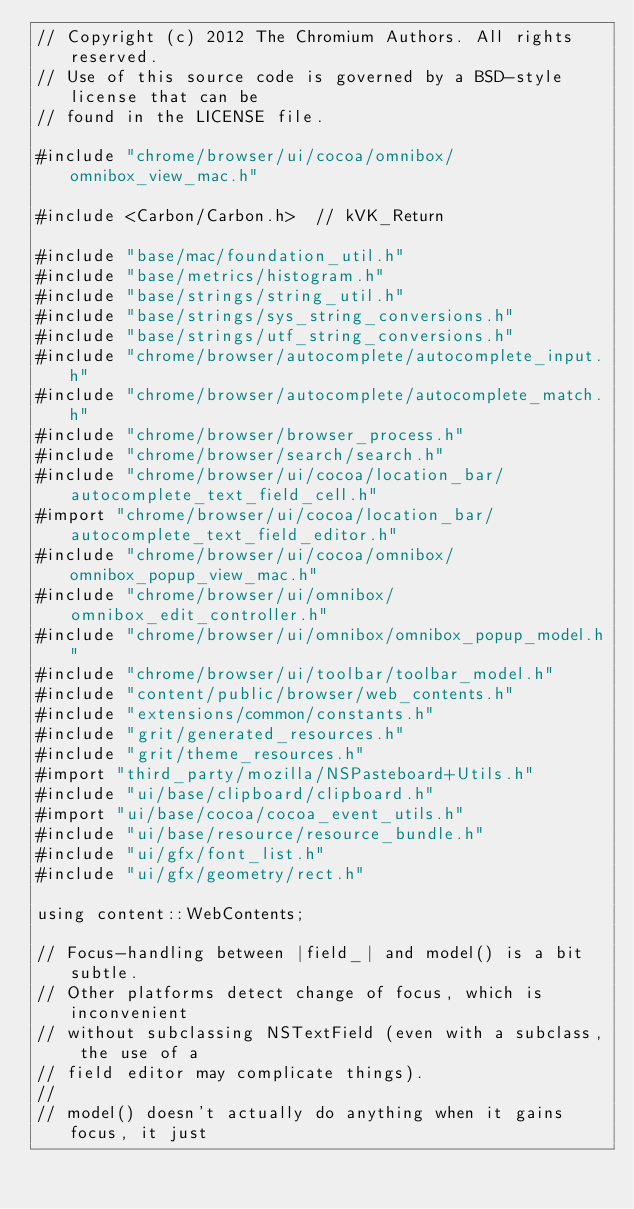<code> <loc_0><loc_0><loc_500><loc_500><_ObjectiveC_>// Copyright (c) 2012 The Chromium Authors. All rights reserved.
// Use of this source code is governed by a BSD-style license that can be
// found in the LICENSE file.

#include "chrome/browser/ui/cocoa/omnibox/omnibox_view_mac.h"

#include <Carbon/Carbon.h>  // kVK_Return

#include "base/mac/foundation_util.h"
#include "base/metrics/histogram.h"
#include "base/strings/string_util.h"
#include "base/strings/sys_string_conversions.h"
#include "base/strings/utf_string_conversions.h"
#include "chrome/browser/autocomplete/autocomplete_input.h"
#include "chrome/browser/autocomplete/autocomplete_match.h"
#include "chrome/browser/browser_process.h"
#include "chrome/browser/search/search.h"
#include "chrome/browser/ui/cocoa/location_bar/autocomplete_text_field_cell.h"
#import "chrome/browser/ui/cocoa/location_bar/autocomplete_text_field_editor.h"
#include "chrome/browser/ui/cocoa/omnibox/omnibox_popup_view_mac.h"
#include "chrome/browser/ui/omnibox/omnibox_edit_controller.h"
#include "chrome/browser/ui/omnibox/omnibox_popup_model.h"
#include "chrome/browser/ui/toolbar/toolbar_model.h"
#include "content/public/browser/web_contents.h"
#include "extensions/common/constants.h"
#include "grit/generated_resources.h"
#include "grit/theme_resources.h"
#import "third_party/mozilla/NSPasteboard+Utils.h"
#include "ui/base/clipboard/clipboard.h"
#import "ui/base/cocoa/cocoa_event_utils.h"
#include "ui/base/resource/resource_bundle.h"
#include "ui/gfx/font_list.h"
#include "ui/gfx/geometry/rect.h"

using content::WebContents;

// Focus-handling between |field_| and model() is a bit subtle.
// Other platforms detect change of focus, which is inconvenient
// without subclassing NSTextField (even with a subclass, the use of a
// field editor may complicate things).
//
// model() doesn't actually do anything when it gains focus, it just</code> 